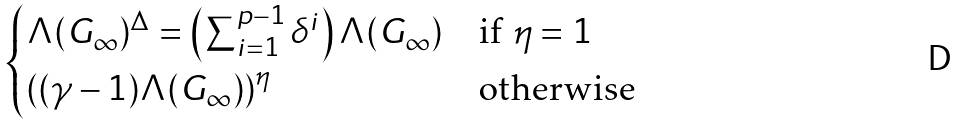Convert formula to latex. <formula><loc_0><loc_0><loc_500><loc_500>\begin{cases} \Lambda ( G _ { \infty } ) ^ { \Delta } = \left ( \sum _ { i = 1 } ^ { p - 1 } \delta ^ { i } \right ) \Lambda ( G _ { \infty } ) & \text {if $\eta=1$} \\ \left ( ( \gamma - 1 ) \Lambda ( G _ { \infty } ) \right ) ^ { \eta } & \text {otherwise} \end{cases}</formula> 